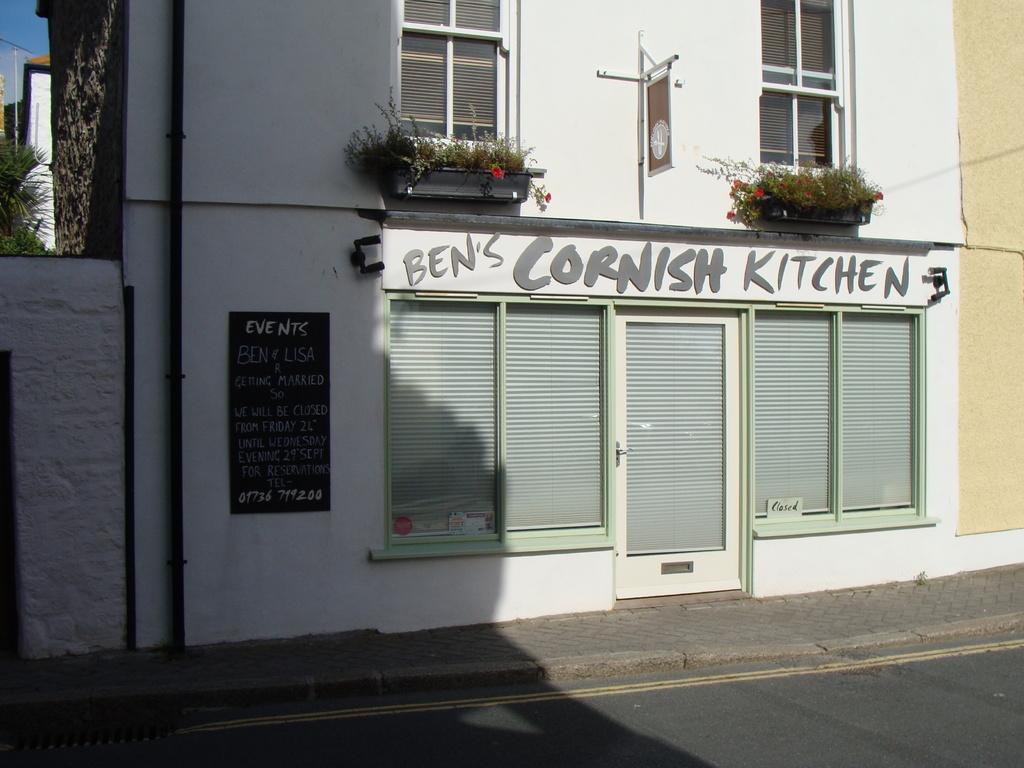What type of structures are visible in the image? There are houses in the image. What architectural features can be seen on the houses? There are windows and a door visible on the houses. What additional objects are present in the image? There are boards with text and plants in the image. Can you describe the natural elements in the image? There is a tree and the sky visible in the image. What type of frame is used to support the achiever in the image? There is no achiever or frame present in the image. What type of wind can be seen blowing through the zephyr in the image? There is no zephyr or wind present in the image. 